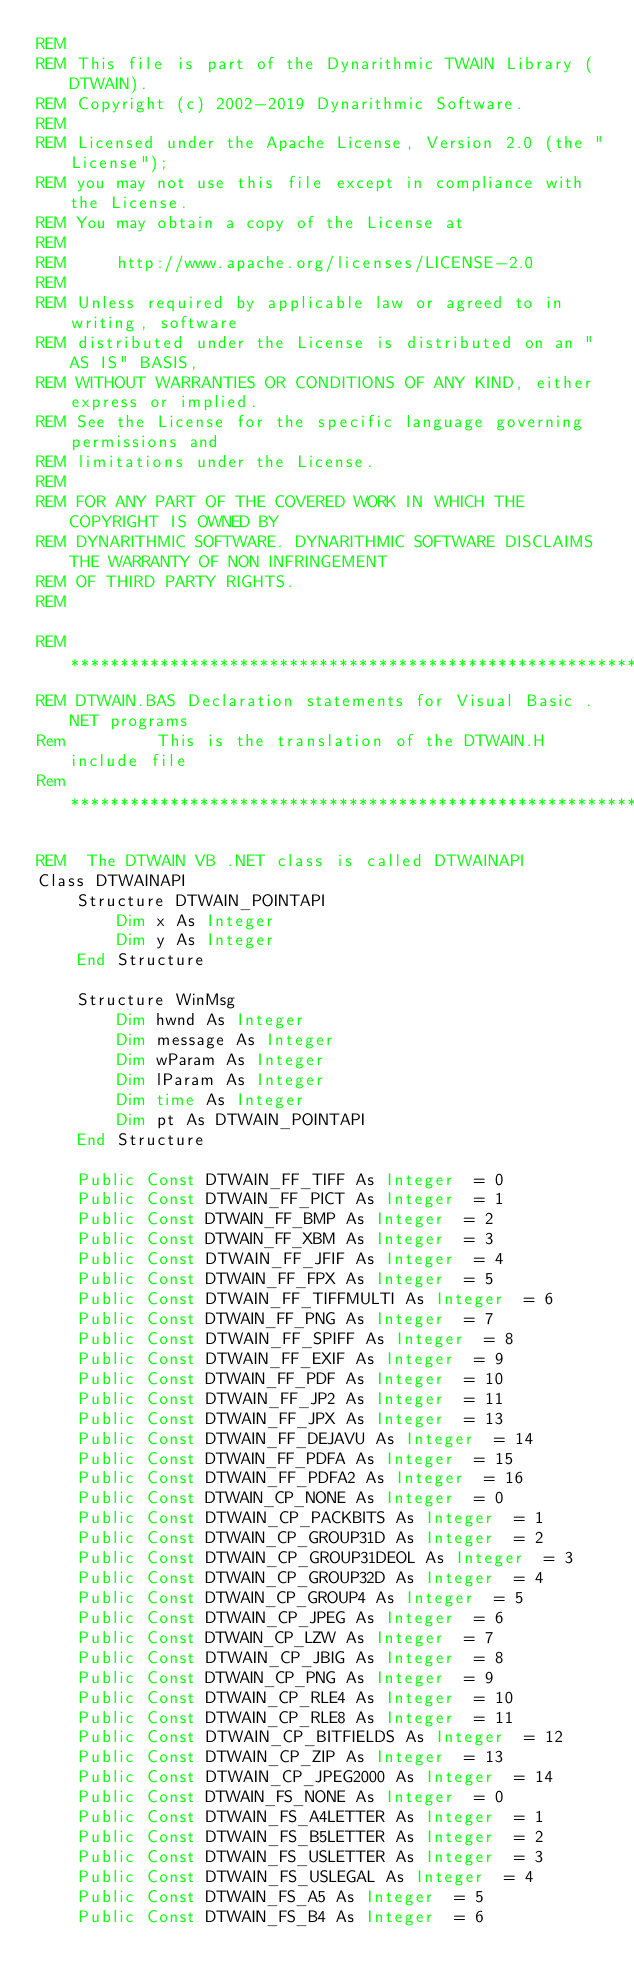<code> <loc_0><loc_0><loc_500><loc_500><_VisualBasic_>REM
REM This file is part of the Dynarithmic TWAIN Library (DTWAIN).                          
REM Copyright (c) 2002-2019 Dynarithmic Software.                                         
REM
REM Licensed under the Apache License, Version 2.0 (the "License");                       
REM you may not use this file except in compliance with the License.                      
REM You may obtain a copy of the License at                                               
REM
REM     http://www.apache.org/licenses/LICENSE-2.0                                        
REM
REM Unless required by applicable law or agreed to in writing, software                   
REM distributed under the License is distributed on an "AS IS" BASIS,                     
REM WITHOUT WARRANTIES OR CONDITIONS OF ANY KIND, either express or implied.              
REM See the License for the specific language governing permissions and                   
REM limitations under the License.                                                        
REM                                                                                       
REM FOR ANY PART OF THE COVERED WORK IN WHICH THE COPYRIGHT IS OWNED BY                   
REM DYNARITHMIC SOFTWARE. DYNARITHMIC SOFTWARE DISCLAIMS THE WARRANTY OF NON INFRINGEMENT 
REM OF THIRD PARTY RIGHTS.                                                                
REM

REM ******************************************************************************
REM DTWAIN.BAS Declaration statements for Visual Basic .NET programs
Rem         This is the translation of the DTWAIN.H include file
Rem *****************************************************************************

REM  The DTWAIN VB .NET class is called DTWAINAPI
Class DTWAINAPI
    Structure DTWAIN_POINTAPI
        Dim x As Integer
        Dim y As Integer
    End Structure

    Structure WinMsg
        Dim hwnd As Integer
        Dim message As Integer
        Dim wParam As Integer
        Dim lParam As Integer
        Dim time As Integer
        Dim pt As DTWAIN_POINTAPI
    End Structure

    Public Const DTWAIN_FF_TIFF As Integer  = 0
    Public Const DTWAIN_FF_PICT As Integer  = 1
    Public Const DTWAIN_FF_BMP As Integer  = 2
    Public Const DTWAIN_FF_XBM As Integer  = 3
    Public Const DTWAIN_FF_JFIF As Integer  = 4
    Public Const DTWAIN_FF_FPX As Integer  = 5
    Public Const DTWAIN_FF_TIFFMULTI As Integer  = 6
    Public Const DTWAIN_FF_PNG As Integer  = 7
    Public Const DTWAIN_FF_SPIFF As Integer  = 8
    Public Const DTWAIN_FF_EXIF As Integer  = 9
    Public Const DTWAIN_FF_PDF As Integer  = 10
    Public Const DTWAIN_FF_JP2 As Integer  = 11
    Public Const DTWAIN_FF_JPX As Integer  = 13
    Public Const DTWAIN_FF_DEJAVU As Integer  = 14
    Public Const DTWAIN_FF_PDFA As Integer  = 15
    Public Const DTWAIN_FF_PDFA2 As Integer  = 16
    Public Const DTWAIN_CP_NONE As Integer  = 0
    Public Const DTWAIN_CP_PACKBITS As Integer  = 1
    Public Const DTWAIN_CP_GROUP31D As Integer  = 2
    Public Const DTWAIN_CP_GROUP31DEOL As Integer  = 3
    Public Const DTWAIN_CP_GROUP32D As Integer  = 4
    Public Const DTWAIN_CP_GROUP4 As Integer  = 5
    Public Const DTWAIN_CP_JPEG As Integer  = 6
    Public Const DTWAIN_CP_LZW As Integer  = 7
    Public Const DTWAIN_CP_JBIG As Integer  = 8
    Public Const DTWAIN_CP_PNG As Integer  = 9
    Public Const DTWAIN_CP_RLE4 As Integer  = 10
    Public Const DTWAIN_CP_RLE8 As Integer  = 11
    Public Const DTWAIN_CP_BITFIELDS As Integer  = 12
    Public Const DTWAIN_CP_ZIP As Integer  = 13
    Public Const DTWAIN_CP_JPEG2000 As Integer  = 14
    Public Const DTWAIN_FS_NONE As Integer  = 0
    Public Const DTWAIN_FS_A4LETTER As Integer  = 1
    Public Const DTWAIN_FS_B5LETTER As Integer  = 2
    Public Const DTWAIN_FS_USLETTER As Integer  = 3
    Public Const DTWAIN_FS_USLEGAL As Integer  = 4
    Public Const DTWAIN_FS_A5 As Integer  = 5
    Public Const DTWAIN_FS_B4 As Integer  = 6</code> 